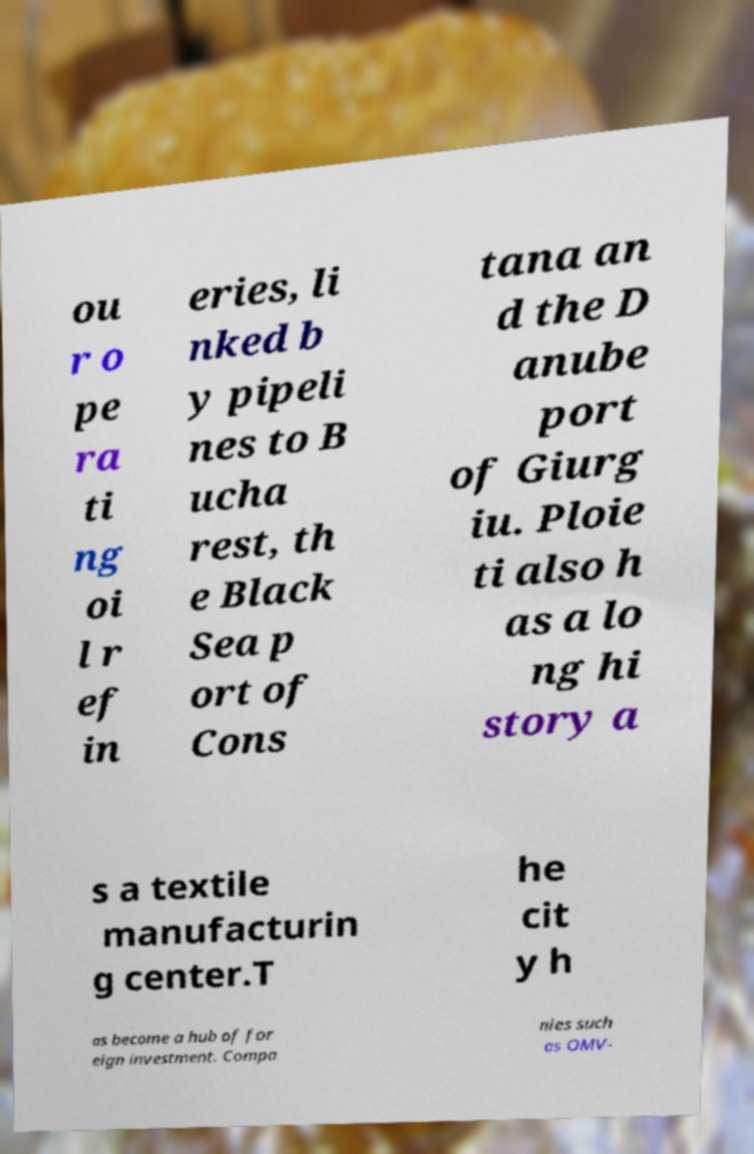Please identify and transcribe the text found in this image. ou r o pe ra ti ng oi l r ef in eries, li nked b y pipeli nes to B ucha rest, th e Black Sea p ort of Cons tana an d the D anube port of Giurg iu. Ploie ti also h as a lo ng hi story a s a textile manufacturin g center.T he cit y h as become a hub of for eign investment. Compa nies such as OMV- 